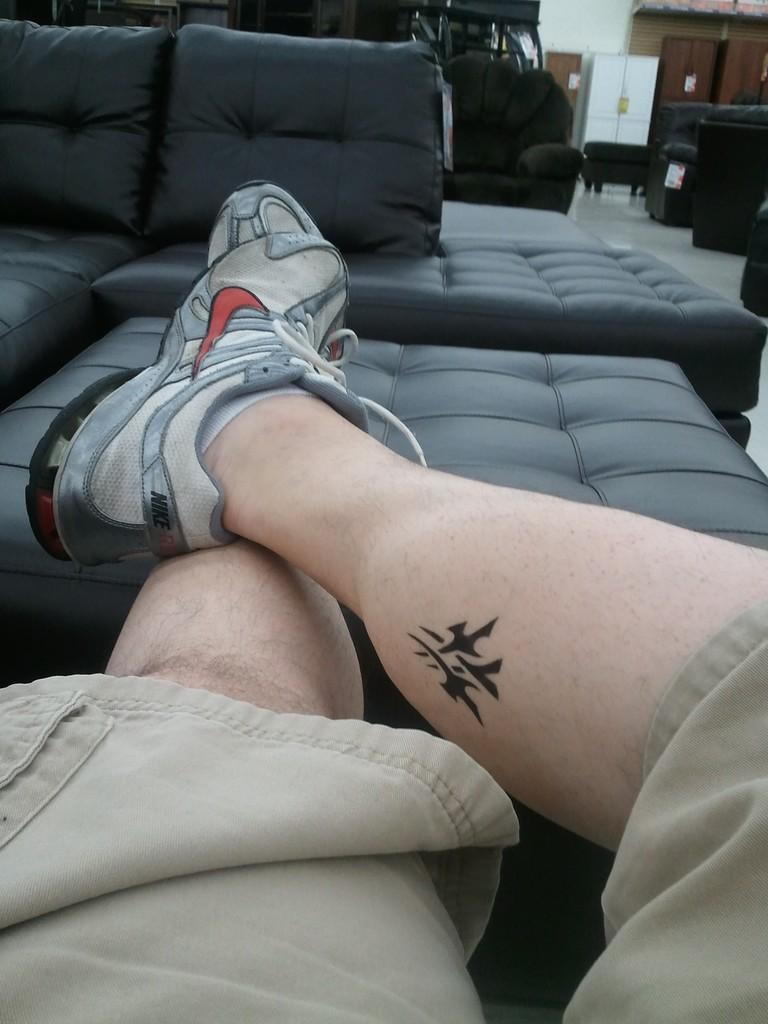What can be seen at the bottom of the image? There are person legs with shoes in the image. What is located in the background of the image? There is a couch, pillows, a cupboard, a door, and a wall in the background of the image. What invention is being demonstrated in the image? There is no invention being demonstrated in the image; it simply shows person legs with shoes and various items in the background. 